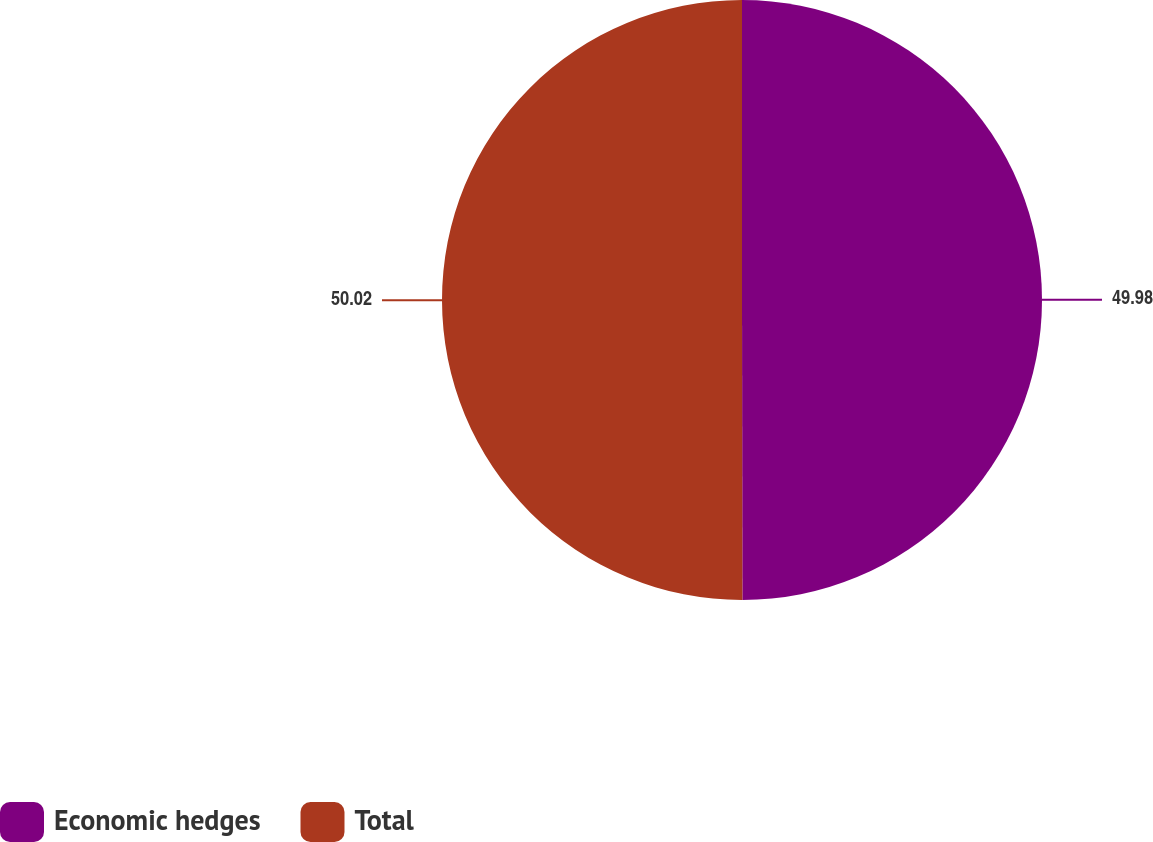<chart> <loc_0><loc_0><loc_500><loc_500><pie_chart><fcel>Economic hedges<fcel>Total<nl><fcel>49.98%<fcel>50.02%<nl></chart> 